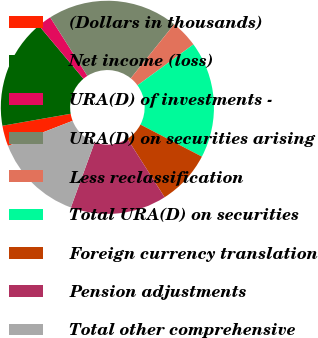Convert chart to OTSL. <chart><loc_0><loc_0><loc_500><loc_500><pie_chart><fcel>(Dollars in thousands)<fcel>Net income (loss)<fcel>URA(D) of investments -<fcel>URA(D) on securities arising<fcel>Less reclassification<fcel>Total URA(D) on securities<fcel>Foreign currency translation<fcel>Pension adjustments<fcel>Total other comprehensive<nl><fcel>3.13%<fcel>16.66%<fcel>2.09%<fcel>19.79%<fcel>4.17%<fcel>17.7%<fcel>8.33%<fcel>14.58%<fcel>13.54%<nl></chart> 